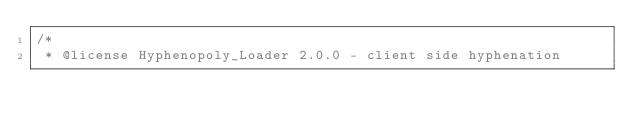<code> <loc_0><loc_0><loc_500><loc_500><_JavaScript_>/*
 * @license Hyphenopoly_Loader 2.0.0 - client side hyphenation</code> 